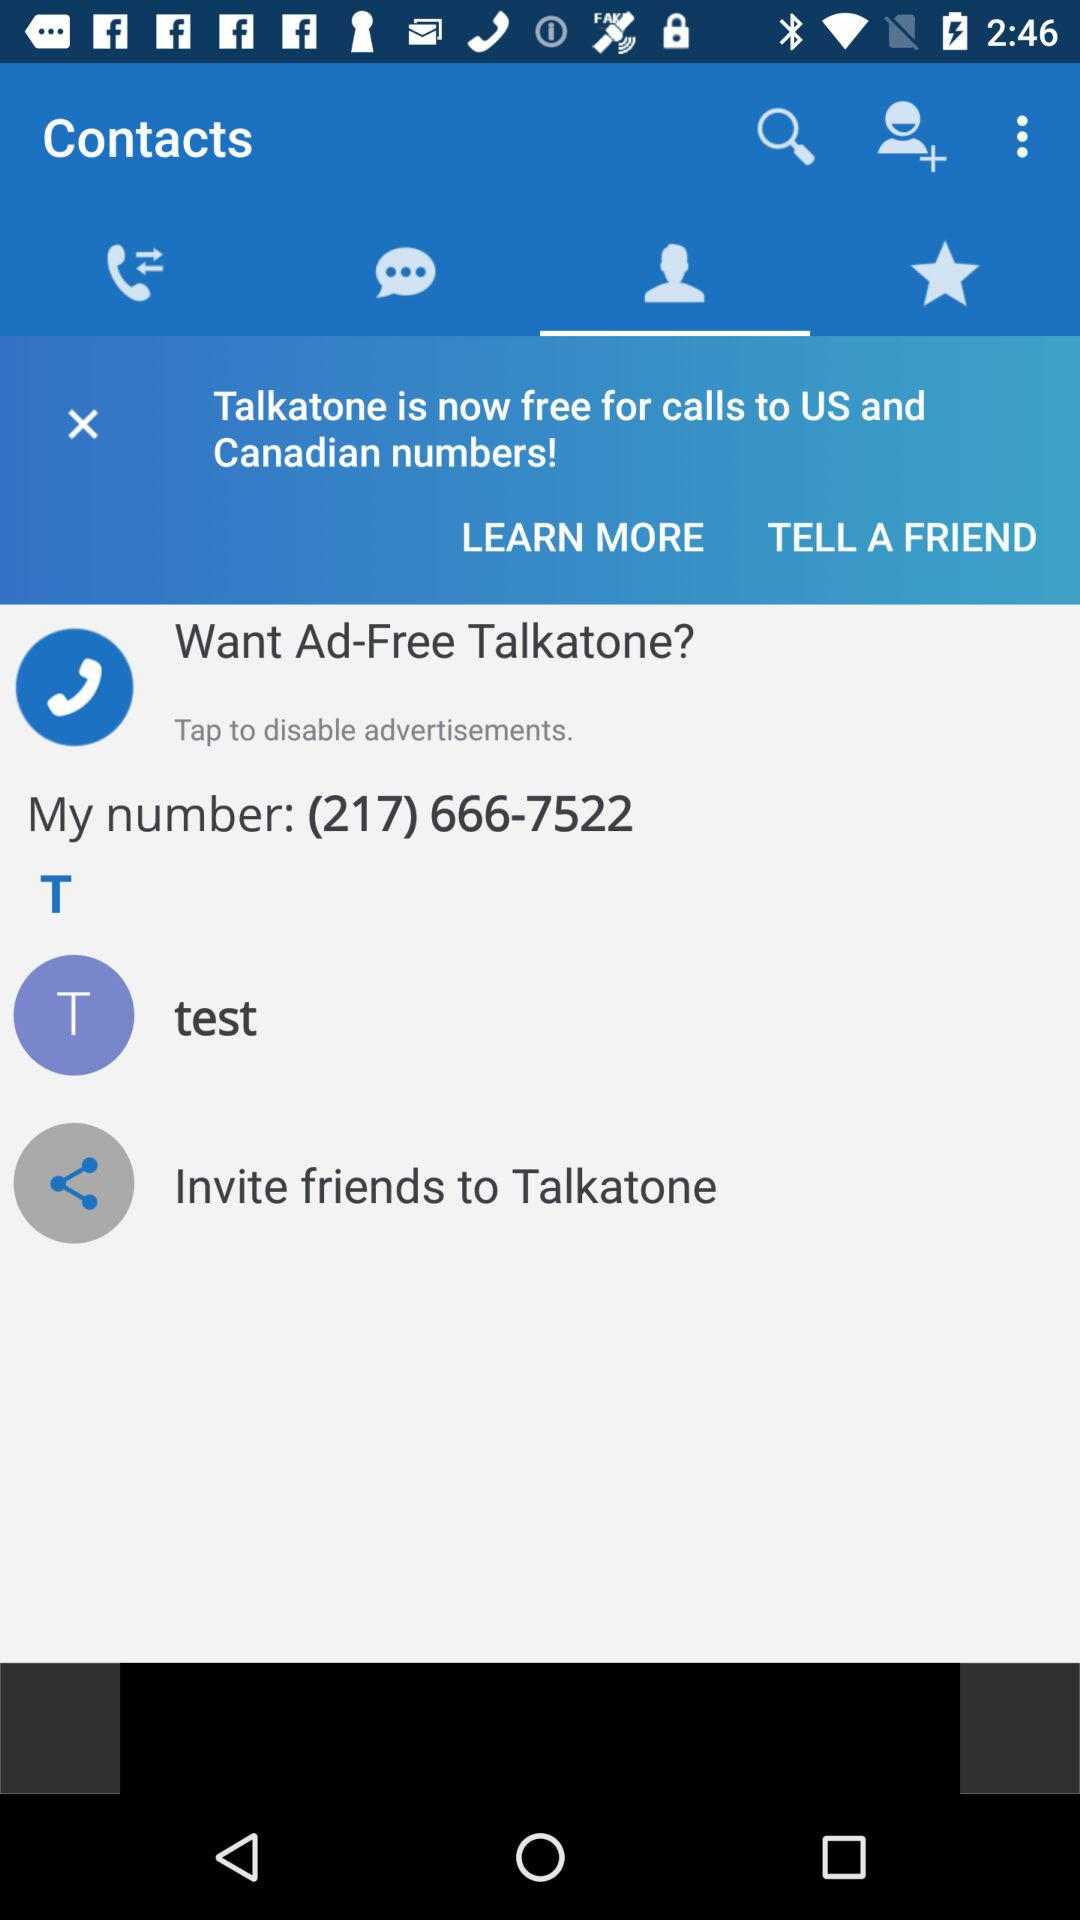What's the area code? The area code is 217. 